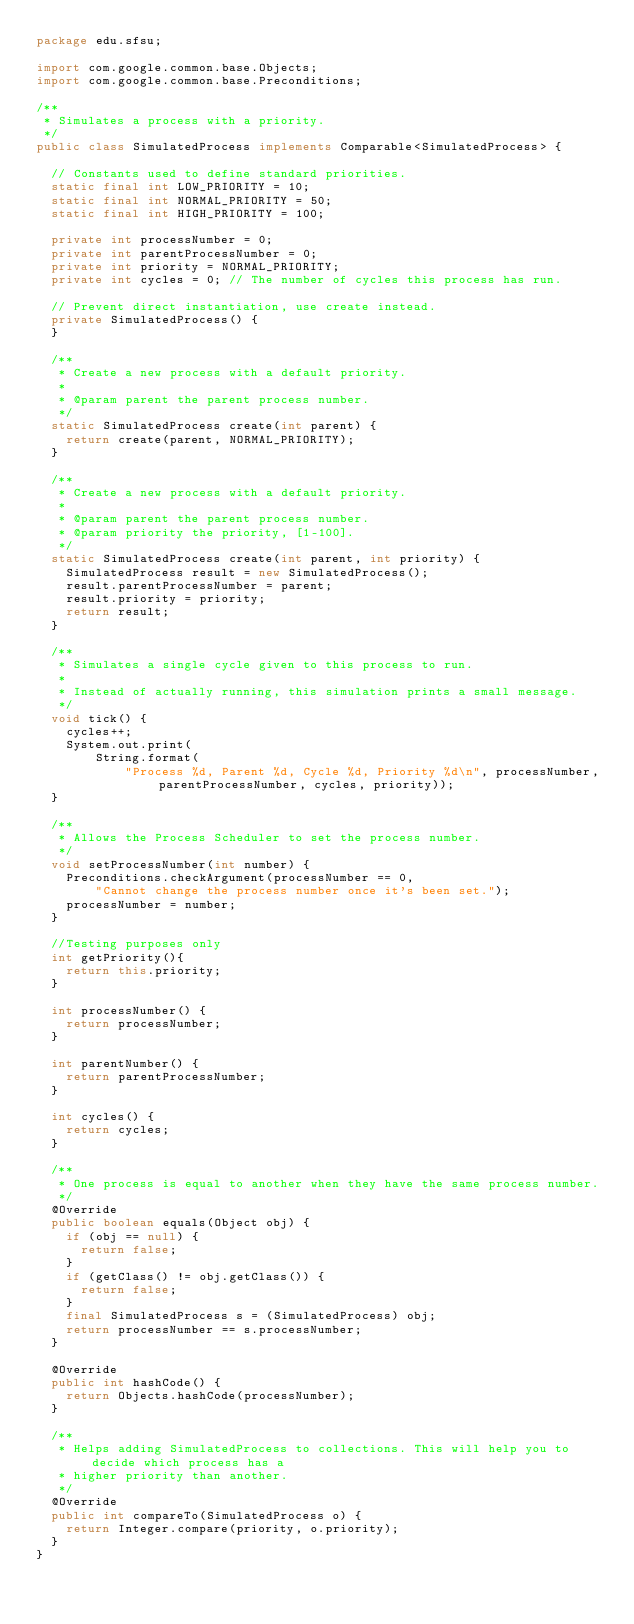Convert code to text. <code><loc_0><loc_0><loc_500><loc_500><_Java_>package edu.sfsu;

import com.google.common.base.Objects;
import com.google.common.base.Preconditions;

/**
 * Simulates a process with a priority.
 */
public class SimulatedProcess implements Comparable<SimulatedProcess> {

  // Constants used to define standard priorities.
  static final int LOW_PRIORITY = 10;
  static final int NORMAL_PRIORITY = 50;
  static final int HIGH_PRIORITY = 100;

  private int processNumber = 0;
  private int parentProcessNumber = 0;
  private int priority = NORMAL_PRIORITY;
  private int cycles = 0; // The number of cycles this process has run.

  // Prevent direct instantiation, use create instead.
  private SimulatedProcess() {
  }

  /**
   * Create a new process with a default priority.
   *
   * @param parent the parent process number.
   */
  static SimulatedProcess create(int parent) {
    return create(parent, NORMAL_PRIORITY);
  }

  /**
   * Create a new process with a default priority.
   *
   * @param parent the parent process number.
   * @param priority the priority, [1-100].
   */
  static SimulatedProcess create(int parent, int priority) {
    SimulatedProcess result = new SimulatedProcess();
    result.parentProcessNumber = parent;
    result.priority = priority;
    return result;
  }

  /**
   * Simulates a single cycle given to this process to run.
   *
   * Instead of actually running, this simulation prints a small message.
   */
  void tick() {
    cycles++;
    System.out.print(
        String.format(
            "Process %d, Parent %d, Cycle %d, Priority %d\n", processNumber, parentProcessNumber, cycles, priority));
  }

  /**
   * Allows the Process Scheduler to set the process number.
   */
  void setProcessNumber(int number) {
    Preconditions.checkArgument(processNumber == 0,
        "Cannot change the process number once it's been set.");
    processNumber = number;
  }

  //Testing purposes only
  int getPriority(){
    return this.priority;
  }

  int processNumber() {
    return processNumber;
  }

  int parentNumber() {
    return parentProcessNumber;
  }

  int cycles() {
    return cycles;
  }

  /**
   * One process is equal to another when they have the same process number.
   */
  @Override
  public boolean equals(Object obj) {
    if (obj == null) {
      return false;
    }
    if (getClass() != obj.getClass()) {
      return false;
    }
    final SimulatedProcess s = (SimulatedProcess) obj;
    return processNumber == s.processNumber;
  }

  @Override
  public int hashCode() {
    return Objects.hashCode(processNumber);
  }

  /**
   * Helps adding SimulatedProcess to collections. This will help you to decide which process has a
   * higher priority than another.
   */
  @Override
  public int compareTo(SimulatedProcess o) {
    return Integer.compare(priority, o.priority);
  }
}
</code> 